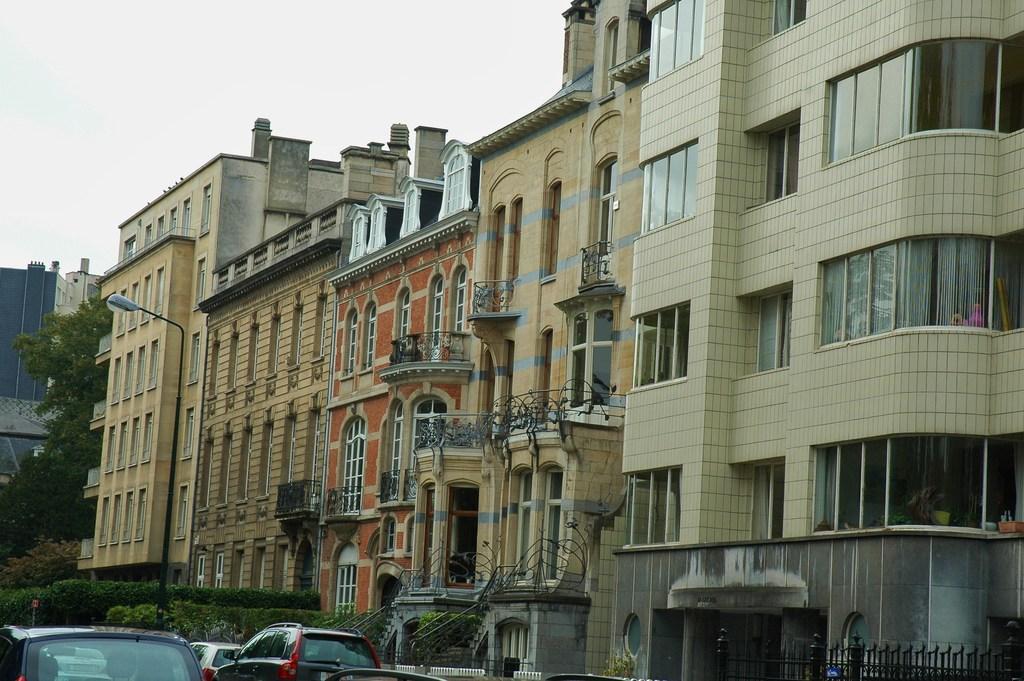Can you describe this image briefly? On the left there are cars, plants and trees. In the center of the picture there are buildings and street light. On the top it is sky, sky is cloudy. 